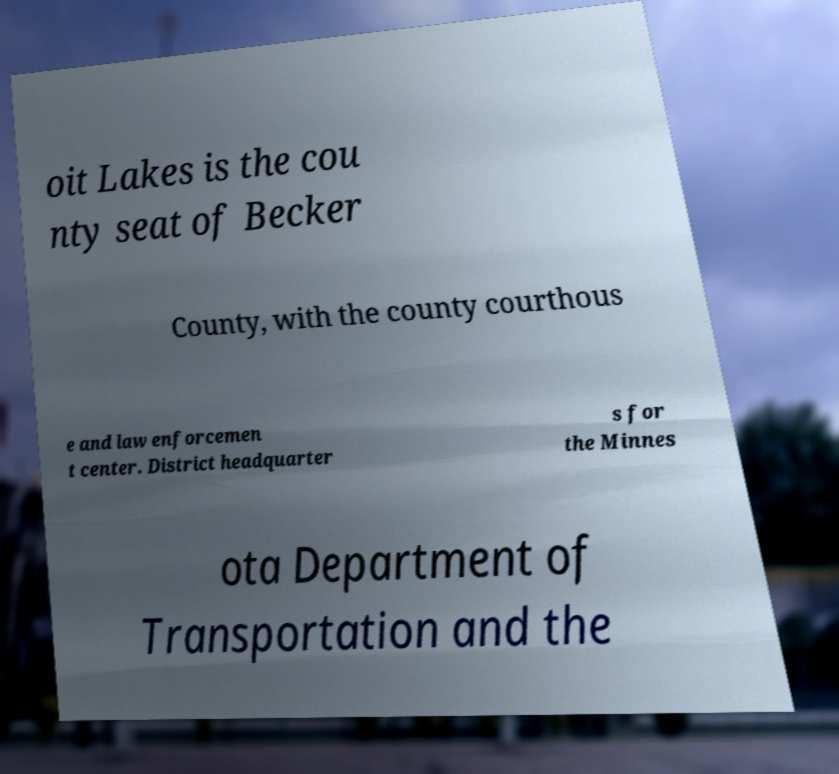There's text embedded in this image that I need extracted. Can you transcribe it verbatim? oit Lakes is the cou nty seat of Becker County, with the county courthous e and law enforcemen t center. District headquarter s for the Minnes ota Department of Transportation and the 